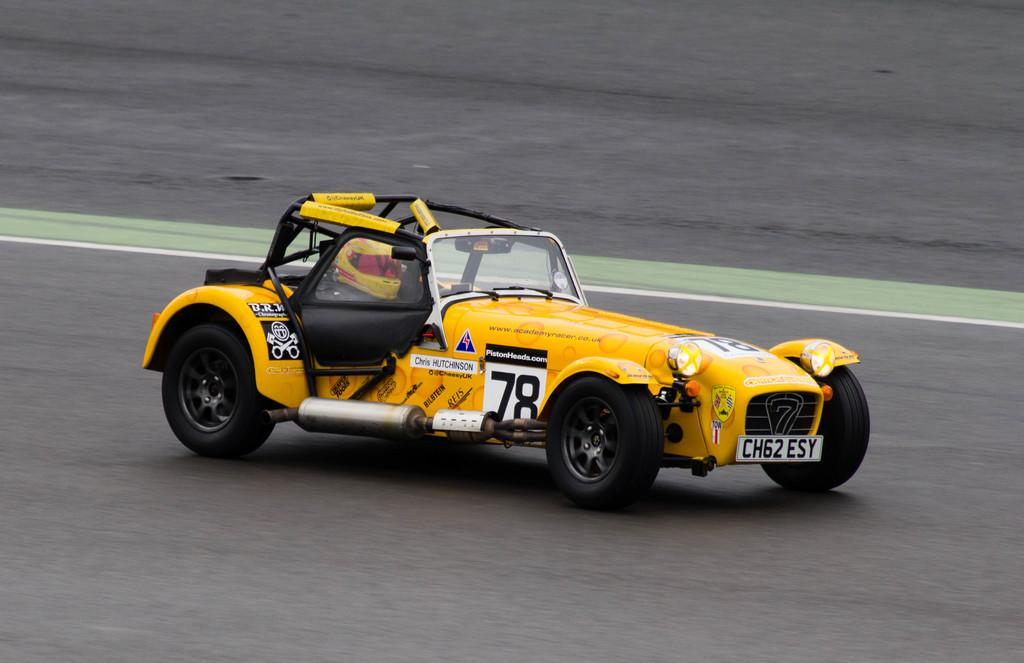What is the main subject in the center of the image? There is a racing car in the center of the image. What is visible at the bottom of the image? There is a road at the bottom of the image. What type of lock can be seen securing the office door in the image? There is no lock or office door present in the image; it features a racing car and a road. 